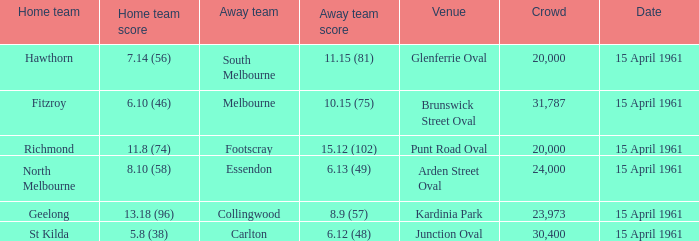Parse the full table. {'header': ['Home team', 'Home team score', 'Away team', 'Away team score', 'Venue', 'Crowd', 'Date'], 'rows': [['Hawthorn', '7.14 (56)', 'South Melbourne', '11.15 (81)', 'Glenferrie Oval', '20,000', '15 April 1961'], ['Fitzroy', '6.10 (46)', 'Melbourne', '10.15 (75)', 'Brunswick Street Oval', '31,787', '15 April 1961'], ['Richmond', '11.8 (74)', 'Footscray', '15.12 (102)', 'Punt Road Oval', '20,000', '15 April 1961'], ['North Melbourne', '8.10 (58)', 'Essendon', '6.13 (49)', 'Arden Street Oval', '24,000', '15 April 1961'], ['Geelong', '13.18 (96)', 'Collingwood', '8.9 (57)', 'Kardinia Park', '23,973', '15 April 1961'], ['St Kilda', '5.8 (38)', 'Carlton', '6.12 (48)', 'Junction Oval', '30,400', '15 April 1961']]} Which venue had a home team score of 6.10 (46)? Brunswick Street Oval. 